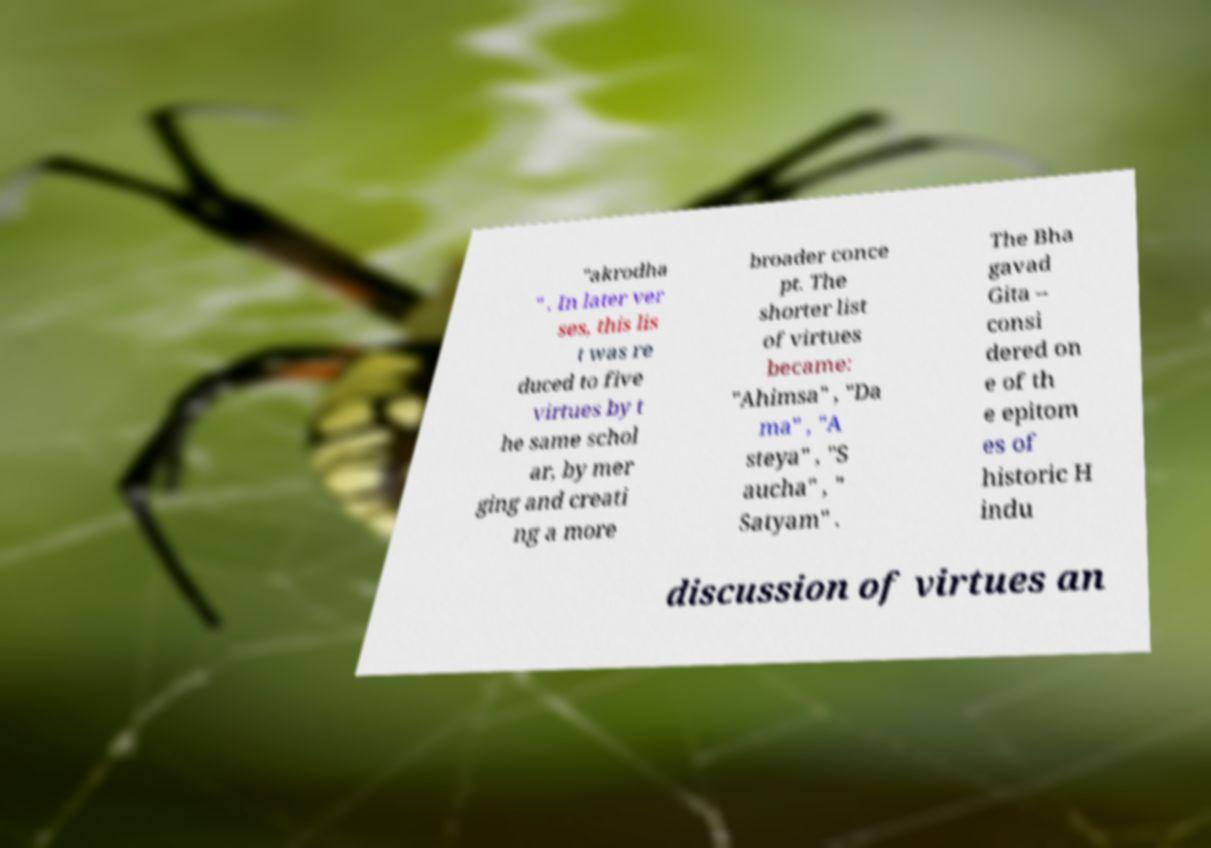Could you assist in decoding the text presented in this image and type it out clearly? "akrodha " . In later ver ses, this lis t was re duced to five virtues by t he same schol ar, by mer ging and creati ng a more broader conce pt. The shorter list of virtues became: "Ahimsa" , "Da ma" , "A steya" , "S aucha" , " Satyam" . The Bha gavad Gita – consi dered on e of th e epitom es of historic H indu discussion of virtues an 